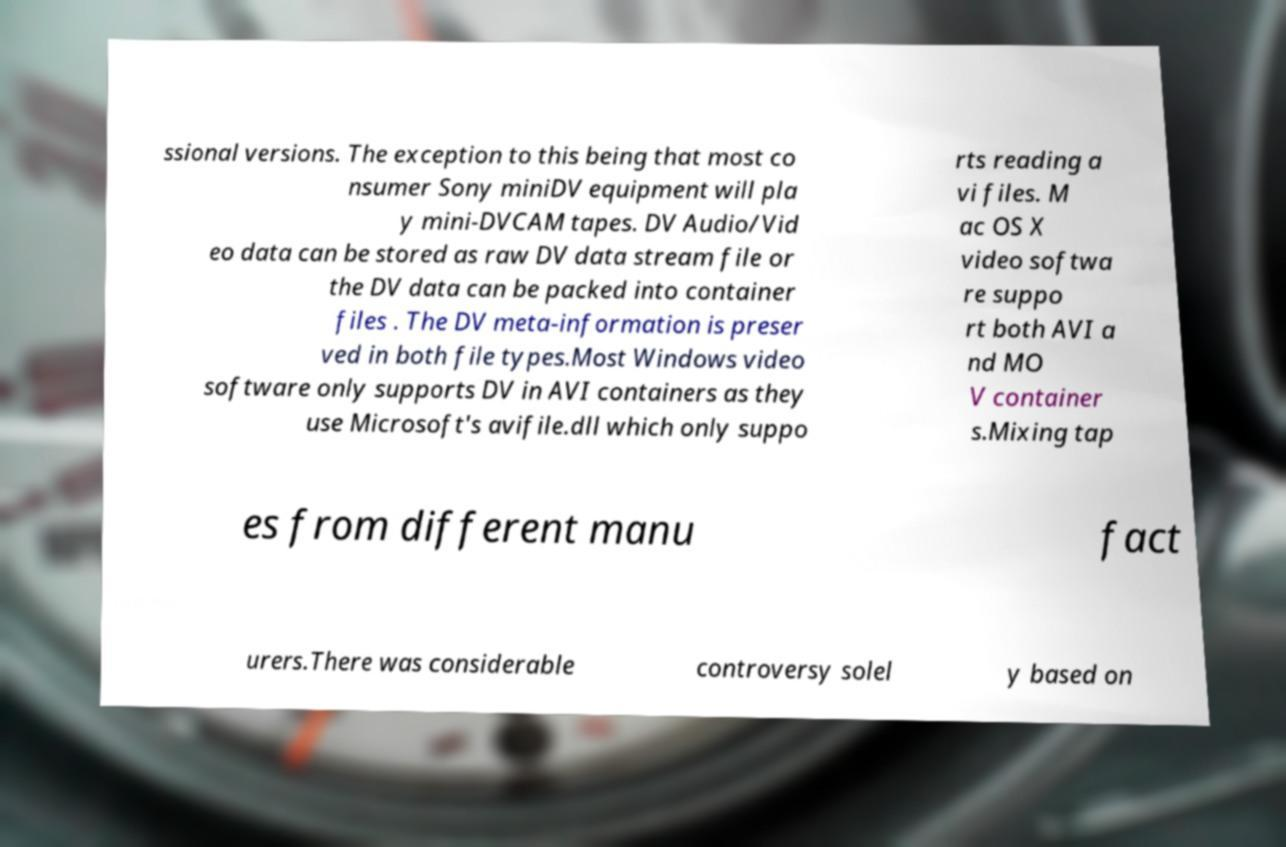What messages or text are displayed in this image? I need them in a readable, typed format. ssional versions. The exception to this being that most co nsumer Sony miniDV equipment will pla y mini-DVCAM tapes. DV Audio/Vid eo data can be stored as raw DV data stream file or the DV data can be packed into container files . The DV meta-information is preser ved in both file types.Most Windows video software only supports DV in AVI containers as they use Microsoft's avifile.dll which only suppo rts reading a vi files. M ac OS X video softwa re suppo rt both AVI a nd MO V container s.Mixing tap es from different manu fact urers.There was considerable controversy solel y based on 